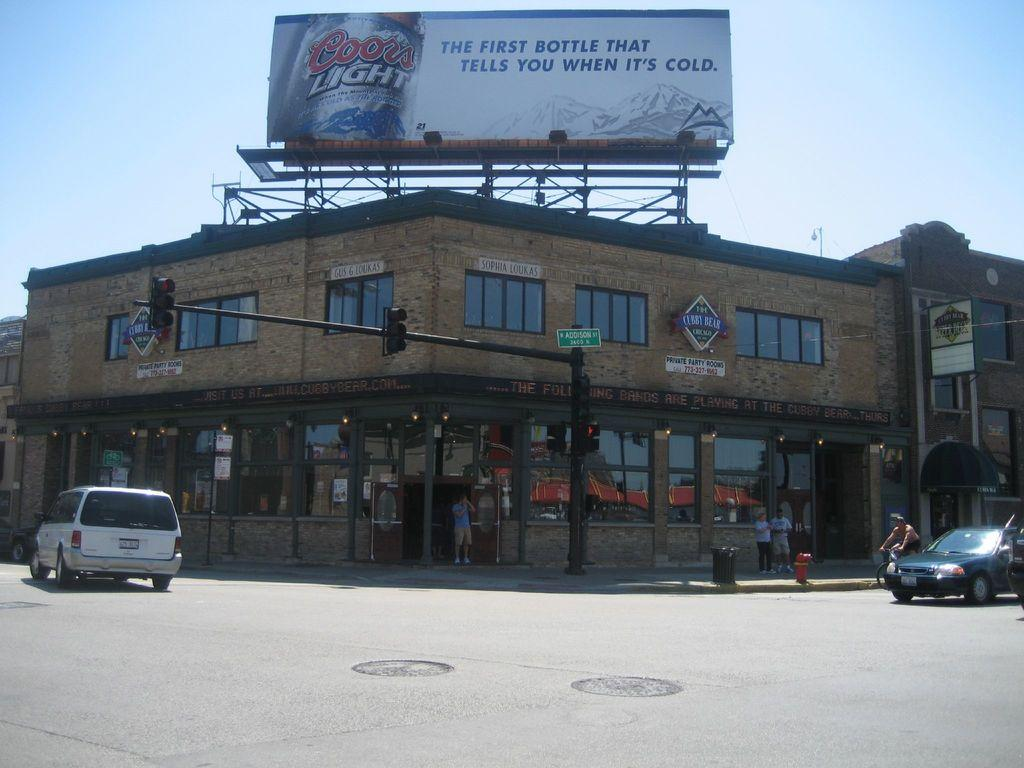<image>
Present a compact description of the photo's key features. A bilboard has an ad for Coors Light. 